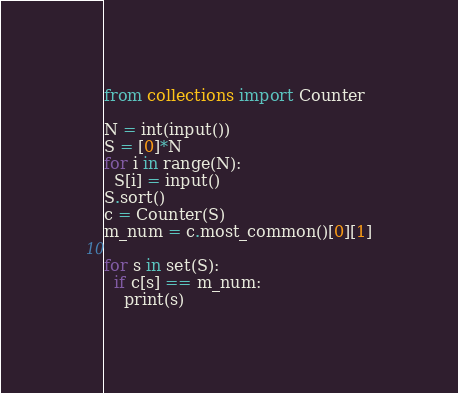<code> <loc_0><loc_0><loc_500><loc_500><_Python_>from collections import Counter

N = int(input())
S = [0]*N
for i in range(N):
  S[i] = input()  
S.sort()
c = Counter(S)
m_num = c.most_common()[0][1]

for s in set(S):
  if c[s] == m_num:
    print(s)</code> 